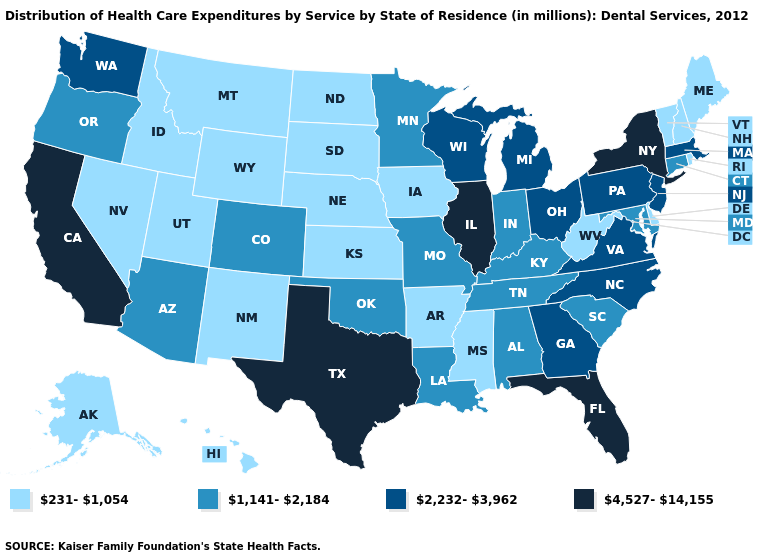What is the lowest value in states that border Kentucky?
Give a very brief answer. 231-1,054. What is the lowest value in the Northeast?
Be succinct. 231-1,054. Name the states that have a value in the range 4,527-14,155?
Keep it brief. California, Florida, Illinois, New York, Texas. What is the value of Arkansas?
Give a very brief answer. 231-1,054. Name the states that have a value in the range 1,141-2,184?
Keep it brief. Alabama, Arizona, Colorado, Connecticut, Indiana, Kentucky, Louisiana, Maryland, Minnesota, Missouri, Oklahoma, Oregon, South Carolina, Tennessee. Which states have the lowest value in the USA?
Short answer required. Alaska, Arkansas, Delaware, Hawaii, Idaho, Iowa, Kansas, Maine, Mississippi, Montana, Nebraska, Nevada, New Hampshire, New Mexico, North Dakota, Rhode Island, South Dakota, Utah, Vermont, West Virginia, Wyoming. What is the value of Hawaii?
Write a very short answer. 231-1,054. Does the first symbol in the legend represent the smallest category?
Concise answer only. Yes. Name the states that have a value in the range 231-1,054?
Write a very short answer. Alaska, Arkansas, Delaware, Hawaii, Idaho, Iowa, Kansas, Maine, Mississippi, Montana, Nebraska, Nevada, New Hampshire, New Mexico, North Dakota, Rhode Island, South Dakota, Utah, Vermont, West Virginia, Wyoming. Among the states that border Minnesota , which have the highest value?
Concise answer only. Wisconsin. Name the states that have a value in the range 4,527-14,155?
Give a very brief answer. California, Florida, Illinois, New York, Texas. Name the states that have a value in the range 1,141-2,184?
Write a very short answer. Alabama, Arizona, Colorado, Connecticut, Indiana, Kentucky, Louisiana, Maryland, Minnesota, Missouri, Oklahoma, Oregon, South Carolina, Tennessee. What is the lowest value in the West?
Write a very short answer. 231-1,054. Name the states that have a value in the range 2,232-3,962?
Be succinct. Georgia, Massachusetts, Michigan, New Jersey, North Carolina, Ohio, Pennsylvania, Virginia, Washington, Wisconsin. How many symbols are there in the legend?
Write a very short answer. 4. 